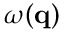Convert formula to latex. <formula><loc_0><loc_0><loc_500><loc_500>\omega ( q )</formula> 